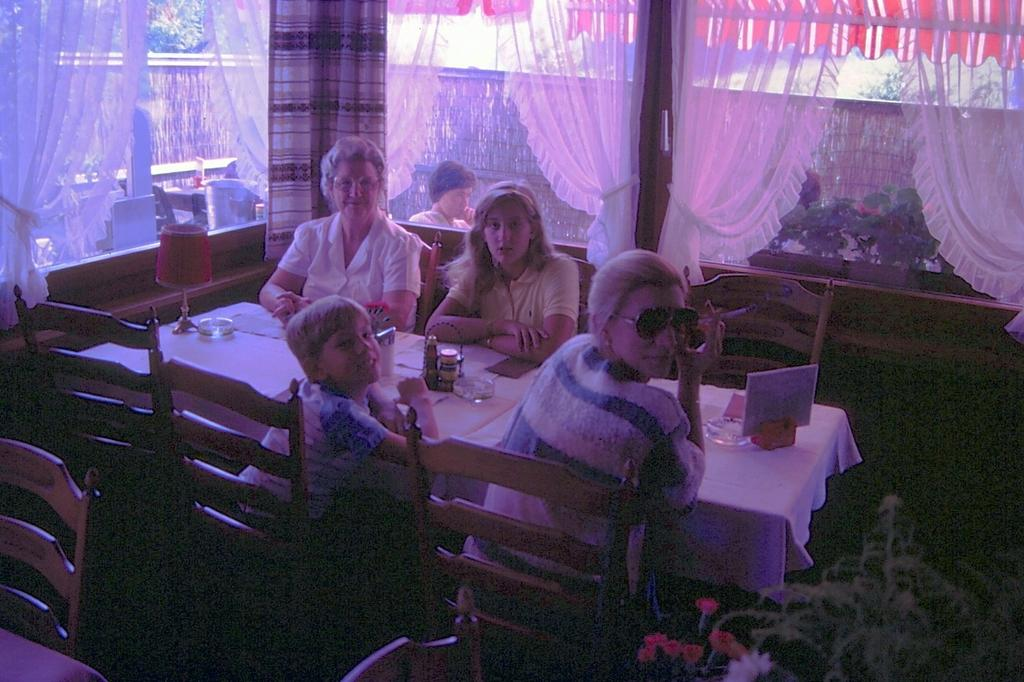What type of window treatment is visible in the image? There are curtains in the image. What can be seen through the windows in the image? There are windows in the image, but the view through them is not specified. What is the background of the image made of? There is a wall in the image. What are the people in the image doing? There are people sitting on chairs in the image. What furniture is present in the image? There is a table in the image. What is on top of the table in the image? There is a white color cloth on the table. What type of brass vessel is present on the table in the image? There is no brass vessel present on the table in the image; only a white color cloth is mentioned. What type of shock can be seen on the people's faces in the image? There is no indication of any shock or emotion on the people's faces in the image. 